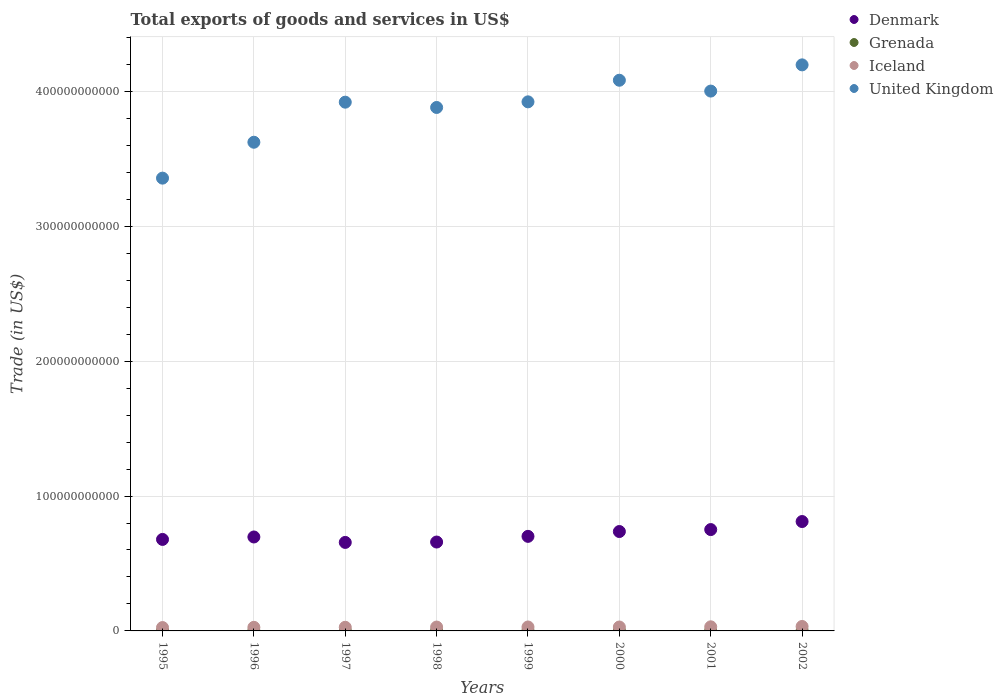How many different coloured dotlines are there?
Provide a succinct answer. 4. What is the total exports of goods and services in Grenada in 1999?
Offer a terse response. 2.18e+08. Across all years, what is the maximum total exports of goods and services in Iceland?
Your response must be concise. 3.30e+09. Across all years, what is the minimum total exports of goods and services in Grenada?
Offer a terse response. 1.24e+08. What is the total total exports of goods and services in United Kingdom in the graph?
Your answer should be very brief. 3.10e+12. What is the difference between the total exports of goods and services in Grenada in 1995 and that in 1996?
Make the answer very short. -7.80e+06. What is the difference between the total exports of goods and services in United Kingdom in 2002 and the total exports of goods and services in Iceland in 1999?
Give a very brief answer. 4.17e+11. What is the average total exports of goods and services in Iceland per year?
Provide a succinct answer. 2.86e+09. In the year 1996, what is the difference between the total exports of goods and services in Iceland and total exports of goods and services in Denmark?
Your answer should be compact. -6.70e+1. What is the ratio of the total exports of goods and services in United Kingdom in 1997 to that in 1998?
Provide a succinct answer. 1.01. What is the difference between the highest and the second highest total exports of goods and services in United Kingdom?
Your answer should be very brief. 1.14e+1. What is the difference between the highest and the lowest total exports of goods and services in Denmark?
Make the answer very short. 1.55e+1. Is the sum of the total exports of goods and services in United Kingdom in 1996 and 1997 greater than the maximum total exports of goods and services in Iceland across all years?
Provide a short and direct response. Yes. Is it the case that in every year, the sum of the total exports of goods and services in Denmark and total exports of goods and services in United Kingdom  is greater than the sum of total exports of goods and services in Iceland and total exports of goods and services in Grenada?
Provide a short and direct response. Yes. Is it the case that in every year, the sum of the total exports of goods and services in Grenada and total exports of goods and services in Denmark  is greater than the total exports of goods and services in United Kingdom?
Your answer should be very brief. No. Is the total exports of goods and services in Denmark strictly greater than the total exports of goods and services in United Kingdom over the years?
Make the answer very short. No. Is the total exports of goods and services in United Kingdom strictly less than the total exports of goods and services in Grenada over the years?
Give a very brief answer. No. How many years are there in the graph?
Provide a short and direct response. 8. What is the difference between two consecutive major ticks on the Y-axis?
Your answer should be very brief. 1.00e+11. Are the values on the major ticks of Y-axis written in scientific E-notation?
Keep it short and to the point. No. Does the graph contain any zero values?
Your response must be concise. No. Does the graph contain grids?
Offer a very short reply. Yes. Where does the legend appear in the graph?
Make the answer very short. Top right. What is the title of the graph?
Offer a terse response. Total exports of goods and services in US$. What is the label or title of the Y-axis?
Make the answer very short. Trade (in US$). What is the Trade (in US$) of Denmark in 1995?
Make the answer very short. 6.78e+1. What is the Trade (in US$) of Grenada in 1995?
Offer a terse response. 1.24e+08. What is the Trade (in US$) in Iceland in 1995?
Provide a succinct answer. 2.49e+09. What is the Trade (in US$) in United Kingdom in 1995?
Your answer should be compact. 3.36e+11. What is the Trade (in US$) of Denmark in 1996?
Offer a very short reply. 6.96e+1. What is the Trade (in US$) of Grenada in 1996?
Offer a terse response. 1.32e+08. What is the Trade (in US$) in Iceland in 1996?
Your answer should be compact. 2.66e+09. What is the Trade (in US$) of United Kingdom in 1996?
Offer a very short reply. 3.62e+11. What is the Trade (in US$) of Denmark in 1997?
Your answer should be compact. 6.56e+1. What is the Trade (in US$) in Grenada in 1997?
Provide a short and direct response. 1.34e+08. What is the Trade (in US$) in Iceland in 1997?
Give a very brief answer. 2.69e+09. What is the Trade (in US$) in United Kingdom in 1997?
Make the answer very short. 3.92e+11. What is the Trade (in US$) of Denmark in 1998?
Your response must be concise. 6.59e+1. What is the Trade (in US$) in Grenada in 1998?
Offer a very short reply. 1.57e+08. What is the Trade (in US$) in Iceland in 1998?
Offer a terse response. 2.87e+09. What is the Trade (in US$) of United Kingdom in 1998?
Give a very brief answer. 3.88e+11. What is the Trade (in US$) of Denmark in 1999?
Give a very brief answer. 7.01e+1. What is the Trade (in US$) in Grenada in 1999?
Give a very brief answer. 2.18e+08. What is the Trade (in US$) of Iceland in 1999?
Your answer should be very brief. 2.92e+09. What is the Trade (in US$) of United Kingdom in 1999?
Provide a succinct answer. 3.92e+11. What is the Trade (in US$) in Denmark in 2000?
Keep it short and to the point. 7.37e+1. What is the Trade (in US$) in Grenada in 2000?
Provide a succinct answer. 2.36e+08. What is the Trade (in US$) of Iceland in 2000?
Ensure brevity in your answer.  2.90e+09. What is the Trade (in US$) in United Kingdom in 2000?
Offer a very short reply. 4.08e+11. What is the Trade (in US$) in Denmark in 2001?
Your answer should be compact. 7.51e+1. What is the Trade (in US$) of Grenada in 2001?
Give a very brief answer. 1.97e+08. What is the Trade (in US$) in Iceland in 2001?
Your response must be concise. 3.04e+09. What is the Trade (in US$) of United Kingdom in 2001?
Offer a terse response. 4.00e+11. What is the Trade (in US$) in Denmark in 2002?
Keep it short and to the point. 8.11e+1. What is the Trade (in US$) of Grenada in 2002?
Keep it short and to the point. 1.73e+08. What is the Trade (in US$) in Iceland in 2002?
Your answer should be compact. 3.30e+09. What is the Trade (in US$) in United Kingdom in 2002?
Keep it short and to the point. 4.20e+11. Across all years, what is the maximum Trade (in US$) of Denmark?
Your answer should be very brief. 8.11e+1. Across all years, what is the maximum Trade (in US$) in Grenada?
Your answer should be compact. 2.36e+08. Across all years, what is the maximum Trade (in US$) in Iceland?
Offer a terse response. 3.30e+09. Across all years, what is the maximum Trade (in US$) of United Kingdom?
Keep it short and to the point. 4.20e+11. Across all years, what is the minimum Trade (in US$) of Denmark?
Ensure brevity in your answer.  6.56e+1. Across all years, what is the minimum Trade (in US$) of Grenada?
Provide a short and direct response. 1.24e+08. Across all years, what is the minimum Trade (in US$) in Iceland?
Ensure brevity in your answer.  2.49e+09. Across all years, what is the minimum Trade (in US$) in United Kingdom?
Offer a very short reply. 3.36e+11. What is the total Trade (in US$) in Denmark in the graph?
Provide a succinct answer. 5.69e+11. What is the total Trade (in US$) of Grenada in the graph?
Your answer should be very brief. 1.37e+09. What is the total Trade (in US$) in Iceland in the graph?
Your answer should be very brief. 2.29e+1. What is the total Trade (in US$) in United Kingdom in the graph?
Provide a short and direct response. 3.10e+12. What is the difference between the Trade (in US$) in Denmark in 1995 and that in 1996?
Make the answer very short. -1.81e+09. What is the difference between the Trade (in US$) of Grenada in 1995 and that in 1996?
Your answer should be compact. -7.80e+06. What is the difference between the Trade (in US$) of Iceland in 1995 and that in 1996?
Offer a terse response. -1.67e+08. What is the difference between the Trade (in US$) in United Kingdom in 1995 and that in 1996?
Your response must be concise. -2.66e+1. What is the difference between the Trade (in US$) in Denmark in 1995 and that in 1997?
Offer a very short reply. 2.22e+09. What is the difference between the Trade (in US$) in Grenada in 1995 and that in 1997?
Your answer should be compact. -1.03e+07. What is the difference between the Trade (in US$) in Iceland in 1995 and that in 1997?
Ensure brevity in your answer.  -1.96e+08. What is the difference between the Trade (in US$) of United Kingdom in 1995 and that in 1997?
Provide a succinct answer. -5.63e+1. What is the difference between the Trade (in US$) in Denmark in 1995 and that in 1998?
Make the answer very short. 1.93e+09. What is the difference between the Trade (in US$) of Grenada in 1995 and that in 1998?
Your response must be concise. -3.36e+07. What is the difference between the Trade (in US$) in Iceland in 1995 and that in 1998?
Provide a succinct answer. -3.78e+08. What is the difference between the Trade (in US$) of United Kingdom in 1995 and that in 1998?
Your answer should be compact. -5.24e+1. What is the difference between the Trade (in US$) of Denmark in 1995 and that in 1999?
Offer a terse response. -2.27e+09. What is the difference between the Trade (in US$) of Grenada in 1995 and that in 1999?
Keep it short and to the point. -9.42e+07. What is the difference between the Trade (in US$) in Iceland in 1995 and that in 1999?
Ensure brevity in your answer.  -4.22e+08. What is the difference between the Trade (in US$) of United Kingdom in 1995 and that in 1999?
Make the answer very short. -5.66e+1. What is the difference between the Trade (in US$) in Denmark in 1995 and that in 2000?
Provide a short and direct response. -5.86e+09. What is the difference between the Trade (in US$) of Grenada in 1995 and that in 2000?
Offer a very short reply. -1.12e+08. What is the difference between the Trade (in US$) in Iceland in 1995 and that in 2000?
Ensure brevity in your answer.  -4.06e+08. What is the difference between the Trade (in US$) of United Kingdom in 1995 and that in 2000?
Offer a terse response. -7.26e+1. What is the difference between the Trade (in US$) in Denmark in 1995 and that in 2001?
Provide a succinct answer. -7.30e+09. What is the difference between the Trade (in US$) of Grenada in 1995 and that in 2001?
Your response must be concise. -7.33e+07. What is the difference between the Trade (in US$) in Iceland in 1995 and that in 2001?
Ensure brevity in your answer.  -5.47e+08. What is the difference between the Trade (in US$) of United Kingdom in 1995 and that in 2001?
Provide a short and direct response. -6.45e+1. What is the difference between the Trade (in US$) of Denmark in 1995 and that in 2002?
Your response must be concise. -1.33e+1. What is the difference between the Trade (in US$) in Grenada in 1995 and that in 2002?
Offer a very short reply. -4.88e+07. What is the difference between the Trade (in US$) of Iceland in 1995 and that in 2002?
Provide a succinct answer. -8.09e+08. What is the difference between the Trade (in US$) in United Kingdom in 1995 and that in 2002?
Your answer should be very brief. -8.40e+1. What is the difference between the Trade (in US$) of Denmark in 1996 and that in 1997?
Offer a very short reply. 4.03e+09. What is the difference between the Trade (in US$) of Grenada in 1996 and that in 1997?
Offer a terse response. -2.47e+06. What is the difference between the Trade (in US$) in Iceland in 1996 and that in 1997?
Keep it short and to the point. -2.97e+07. What is the difference between the Trade (in US$) in United Kingdom in 1996 and that in 1997?
Your response must be concise. -2.97e+1. What is the difference between the Trade (in US$) of Denmark in 1996 and that in 1998?
Offer a very short reply. 3.75e+09. What is the difference between the Trade (in US$) of Grenada in 1996 and that in 1998?
Offer a very short reply. -2.58e+07. What is the difference between the Trade (in US$) of Iceland in 1996 and that in 1998?
Keep it short and to the point. -2.11e+08. What is the difference between the Trade (in US$) in United Kingdom in 1996 and that in 1998?
Offer a terse response. -2.58e+1. What is the difference between the Trade (in US$) in Denmark in 1996 and that in 1999?
Give a very brief answer. -4.60e+08. What is the difference between the Trade (in US$) in Grenada in 1996 and that in 1999?
Ensure brevity in your answer.  -8.64e+07. What is the difference between the Trade (in US$) in Iceland in 1996 and that in 1999?
Give a very brief answer. -2.55e+08. What is the difference between the Trade (in US$) of United Kingdom in 1996 and that in 1999?
Your answer should be very brief. -2.99e+1. What is the difference between the Trade (in US$) in Denmark in 1996 and that in 2000?
Offer a terse response. -4.04e+09. What is the difference between the Trade (in US$) in Grenada in 1996 and that in 2000?
Give a very brief answer. -1.04e+08. What is the difference between the Trade (in US$) of Iceland in 1996 and that in 2000?
Offer a terse response. -2.39e+08. What is the difference between the Trade (in US$) of United Kingdom in 1996 and that in 2000?
Ensure brevity in your answer.  -4.60e+1. What is the difference between the Trade (in US$) of Denmark in 1996 and that in 2001?
Provide a short and direct response. -5.49e+09. What is the difference between the Trade (in US$) in Grenada in 1996 and that in 2001?
Provide a succinct answer. -6.55e+07. What is the difference between the Trade (in US$) of Iceland in 1996 and that in 2001?
Keep it short and to the point. -3.80e+08. What is the difference between the Trade (in US$) of United Kingdom in 1996 and that in 2001?
Your answer should be compact. -3.79e+1. What is the difference between the Trade (in US$) of Denmark in 1996 and that in 2002?
Provide a short and direct response. -1.15e+1. What is the difference between the Trade (in US$) in Grenada in 1996 and that in 2002?
Provide a short and direct response. -4.10e+07. What is the difference between the Trade (in US$) in Iceland in 1996 and that in 2002?
Give a very brief answer. -6.42e+08. What is the difference between the Trade (in US$) in United Kingdom in 1996 and that in 2002?
Make the answer very short. -5.74e+1. What is the difference between the Trade (in US$) of Denmark in 1997 and that in 1998?
Your answer should be compact. -2.83e+08. What is the difference between the Trade (in US$) of Grenada in 1997 and that in 1998?
Your answer should be compact. -2.33e+07. What is the difference between the Trade (in US$) of Iceland in 1997 and that in 1998?
Make the answer very short. -1.82e+08. What is the difference between the Trade (in US$) in United Kingdom in 1997 and that in 1998?
Offer a very short reply. 3.92e+09. What is the difference between the Trade (in US$) of Denmark in 1997 and that in 1999?
Give a very brief answer. -4.49e+09. What is the difference between the Trade (in US$) of Grenada in 1997 and that in 1999?
Ensure brevity in your answer.  -8.40e+07. What is the difference between the Trade (in US$) of Iceland in 1997 and that in 1999?
Your answer should be compact. -2.25e+08. What is the difference between the Trade (in US$) in United Kingdom in 1997 and that in 1999?
Your answer should be very brief. -2.45e+08. What is the difference between the Trade (in US$) in Denmark in 1997 and that in 2000?
Your answer should be very brief. -8.07e+09. What is the difference between the Trade (in US$) in Grenada in 1997 and that in 2000?
Ensure brevity in your answer.  -1.02e+08. What is the difference between the Trade (in US$) of Iceland in 1997 and that in 2000?
Give a very brief answer. -2.10e+08. What is the difference between the Trade (in US$) in United Kingdom in 1997 and that in 2000?
Your response must be concise. -1.63e+1. What is the difference between the Trade (in US$) in Denmark in 1997 and that in 2001?
Offer a terse response. -9.52e+09. What is the difference between the Trade (in US$) of Grenada in 1997 and that in 2001?
Provide a succinct answer. -6.31e+07. What is the difference between the Trade (in US$) of Iceland in 1997 and that in 2001?
Keep it short and to the point. -3.51e+08. What is the difference between the Trade (in US$) of United Kingdom in 1997 and that in 2001?
Offer a very short reply. -8.23e+09. What is the difference between the Trade (in US$) of Denmark in 1997 and that in 2002?
Give a very brief answer. -1.55e+1. What is the difference between the Trade (in US$) in Grenada in 1997 and that in 2002?
Give a very brief answer. -3.85e+07. What is the difference between the Trade (in US$) of Iceland in 1997 and that in 2002?
Provide a succinct answer. -6.13e+08. What is the difference between the Trade (in US$) of United Kingdom in 1997 and that in 2002?
Make the answer very short. -2.77e+1. What is the difference between the Trade (in US$) of Denmark in 1998 and that in 1999?
Offer a very short reply. -4.21e+09. What is the difference between the Trade (in US$) of Grenada in 1998 and that in 1999?
Provide a short and direct response. -6.06e+07. What is the difference between the Trade (in US$) in Iceland in 1998 and that in 1999?
Give a very brief answer. -4.36e+07. What is the difference between the Trade (in US$) in United Kingdom in 1998 and that in 1999?
Your answer should be very brief. -4.17e+09. What is the difference between the Trade (in US$) of Denmark in 1998 and that in 2000?
Provide a succinct answer. -7.79e+09. What is the difference between the Trade (in US$) in Grenada in 1998 and that in 2000?
Keep it short and to the point. -7.83e+07. What is the difference between the Trade (in US$) of Iceland in 1998 and that in 2000?
Your answer should be compact. -2.80e+07. What is the difference between the Trade (in US$) in United Kingdom in 1998 and that in 2000?
Offer a terse response. -2.02e+1. What is the difference between the Trade (in US$) in Denmark in 1998 and that in 2001?
Ensure brevity in your answer.  -9.24e+09. What is the difference between the Trade (in US$) in Grenada in 1998 and that in 2001?
Your answer should be compact. -3.97e+07. What is the difference between the Trade (in US$) in Iceland in 1998 and that in 2001?
Provide a succinct answer. -1.69e+08. What is the difference between the Trade (in US$) of United Kingdom in 1998 and that in 2001?
Make the answer very short. -1.21e+1. What is the difference between the Trade (in US$) in Denmark in 1998 and that in 2002?
Give a very brief answer. -1.52e+1. What is the difference between the Trade (in US$) of Grenada in 1998 and that in 2002?
Provide a short and direct response. -1.52e+07. What is the difference between the Trade (in US$) in Iceland in 1998 and that in 2002?
Your response must be concise. -4.31e+08. What is the difference between the Trade (in US$) in United Kingdom in 1998 and that in 2002?
Ensure brevity in your answer.  -3.16e+1. What is the difference between the Trade (in US$) in Denmark in 1999 and that in 2000?
Provide a succinct answer. -3.58e+09. What is the difference between the Trade (in US$) in Grenada in 1999 and that in 2000?
Your answer should be very brief. -1.77e+07. What is the difference between the Trade (in US$) of Iceland in 1999 and that in 2000?
Ensure brevity in your answer.  1.56e+07. What is the difference between the Trade (in US$) in United Kingdom in 1999 and that in 2000?
Offer a terse response. -1.60e+1. What is the difference between the Trade (in US$) in Denmark in 1999 and that in 2001?
Offer a very short reply. -5.03e+09. What is the difference between the Trade (in US$) in Grenada in 1999 and that in 2001?
Your answer should be very brief. 2.09e+07. What is the difference between the Trade (in US$) in Iceland in 1999 and that in 2001?
Ensure brevity in your answer.  -1.25e+08. What is the difference between the Trade (in US$) of United Kingdom in 1999 and that in 2001?
Ensure brevity in your answer.  -7.98e+09. What is the difference between the Trade (in US$) in Denmark in 1999 and that in 2002?
Your response must be concise. -1.10e+1. What is the difference between the Trade (in US$) in Grenada in 1999 and that in 2002?
Your response must be concise. 4.54e+07. What is the difference between the Trade (in US$) in Iceland in 1999 and that in 2002?
Provide a succinct answer. -3.87e+08. What is the difference between the Trade (in US$) in United Kingdom in 1999 and that in 2002?
Make the answer very short. -2.74e+1. What is the difference between the Trade (in US$) of Denmark in 2000 and that in 2001?
Provide a short and direct response. -1.45e+09. What is the difference between the Trade (in US$) of Grenada in 2000 and that in 2001?
Offer a very short reply. 3.86e+07. What is the difference between the Trade (in US$) in Iceland in 2000 and that in 2001?
Provide a short and direct response. -1.41e+08. What is the difference between the Trade (in US$) of United Kingdom in 2000 and that in 2001?
Provide a short and direct response. 8.04e+09. What is the difference between the Trade (in US$) in Denmark in 2000 and that in 2002?
Your answer should be compact. -7.41e+09. What is the difference between the Trade (in US$) of Grenada in 2000 and that in 2002?
Your answer should be very brief. 6.31e+07. What is the difference between the Trade (in US$) in Iceland in 2000 and that in 2002?
Offer a very short reply. -4.03e+08. What is the difference between the Trade (in US$) of United Kingdom in 2000 and that in 2002?
Ensure brevity in your answer.  -1.14e+1. What is the difference between the Trade (in US$) in Denmark in 2001 and that in 2002?
Offer a very short reply. -5.96e+09. What is the difference between the Trade (in US$) in Grenada in 2001 and that in 2002?
Offer a very short reply. 2.45e+07. What is the difference between the Trade (in US$) in Iceland in 2001 and that in 2002?
Offer a very short reply. -2.62e+08. What is the difference between the Trade (in US$) of United Kingdom in 2001 and that in 2002?
Make the answer very short. -1.94e+1. What is the difference between the Trade (in US$) of Denmark in 1995 and the Trade (in US$) of Grenada in 1996?
Offer a very short reply. 6.77e+1. What is the difference between the Trade (in US$) in Denmark in 1995 and the Trade (in US$) in Iceland in 1996?
Give a very brief answer. 6.52e+1. What is the difference between the Trade (in US$) in Denmark in 1995 and the Trade (in US$) in United Kingdom in 1996?
Provide a short and direct response. -2.94e+11. What is the difference between the Trade (in US$) of Grenada in 1995 and the Trade (in US$) of Iceland in 1996?
Provide a short and direct response. -2.54e+09. What is the difference between the Trade (in US$) in Grenada in 1995 and the Trade (in US$) in United Kingdom in 1996?
Ensure brevity in your answer.  -3.62e+11. What is the difference between the Trade (in US$) of Iceland in 1995 and the Trade (in US$) of United Kingdom in 1996?
Your response must be concise. -3.60e+11. What is the difference between the Trade (in US$) of Denmark in 1995 and the Trade (in US$) of Grenada in 1997?
Provide a short and direct response. 6.77e+1. What is the difference between the Trade (in US$) of Denmark in 1995 and the Trade (in US$) of Iceland in 1997?
Offer a terse response. 6.51e+1. What is the difference between the Trade (in US$) in Denmark in 1995 and the Trade (in US$) in United Kingdom in 1997?
Provide a short and direct response. -3.24e+11. What is the difference between the Trade (in US$) in Grenada in 1995 and the Trade (in US$) in Iceland in 1997?
Give a very brief answer. -2.57e+09. What is the difference between the Trade (in US$) in Grenada in 1995 and the Trade (in US$) in United Kingdom in 1997?
Your response must be concise. -3.92e+11. What is the difference between the Trade (in US$) of Iceland in 1995 and the Trade (in US$) of United Kingdom in 1997?
Your answer should be very brief. -3.90e+11. What is the difference between the Trade (in US$) of Denmark in 1995 and the Trade (in US$) of Grenada in 1998?
Your response must be concise. 6.77e+1. What is the difference between the Trade (in US$) in Denmark in 1995 and the Trade (in US$) in Iceland in 1998?
Ensure brevity in your answer.  6.50e+1. What is the difference between the Trade (in US$) in Denmark in 1995 and the Trade (in US$) in United Kingdom in 1998?
Provide a succinct answer. -3.20e+11. What is the difference between the Trade (in US$) in Grenada in 1995 and the Trade (in US$) in Iceland in 1998?
Your answer should be very brief. -2.75e+09. What is the difference between the Trade (in US$) of Grenada in 1995 and the Trade (in US$) of United Kingdom in 1998?
Keep it short and to the point. -3.88e+11. What is the difference between the Trade (in US$) of Iceland in 1995 and the Trade (in US$) of United Kingdom in 1998?
Ensure brevity in your answer.  -3.86e+11. What is the difference between the Trade (in US$) in Denmark in 1995 and the Trade (in US$) in Grenada in 1999?
Your response must be concise. 6.76e+1. What is the difference between the Trade (in US$) of Denmark in 1995 and the Trade (in US$) of Iceland in 1999?
Your answer should be very brief. 6.49e+1. What is the difference between the Trade (in US$) of Denmark in 1995 and the Trade (in US$) of United Kingdom in 1999?
Make the answer very short. -3.24e+11. What is the difference between the Trade (in US$) of Grenada in 1995 and the Trade (in US$) of Iceland in 1999?
Your answer should be very brief. -2.79e+09. What is the difference between the Trade (in US$) of Grenada in 1995 and the Trade (in US$) of United Kingdom in 1999?
Give a very brief answer. -3.92e+11. What is the difference between the Trade (in US$) of Iceland in 1995 and the Trade (in US$) of United Kingdom in 1999?
Your answer should be very brief. -3.90e+11. What is the difference between the Trade (in US$) of Denmark in 1995 and the Trade (in US$) of Grenada in 2000?
Provide a short and direct response. 6.76e+1. What is the difference between the Trade (in US$) in Denmark in 1995 and the Trade (in US$) in Iceland in 2000?
Give a very brief answer. 6.49e+1. What is the difference between the Trade (in US$) in Denmark in 1995 and the Trade (in US$) in United Kingdom in 2000?
Your answer should be compact. -3.40e+11. What is the difference between the Trade (in US$) of Grenada in 1995 and the Trade (in US$) of Iceland in 2000?
Your answer should be very brief. -2.78e+09. What is the difference between the Trade (in US$) of Grenada in 1995 and the Trade (in US$) of United Kingdom in 2000?
Provide a succinct answer. -4.08e+11. What is the difference between the Trade (in US$) of Iceland in 1995 and the Trade (in US$) of United Kingdom in 2000?
Offer a terse response. -4.06e+11. What is the difference between the Trade (in US$) in Denmark in 1995 and the Trade (in US$) in Grenada in 2001?
Your response must be concise. 6.76e+1. What is the difference between the Trade (in US$) of Denmark in 1995 and the Trade (in US$) of Iceland in 2001?
Your response must be concise. 6.48e+1. What is the difference between the Trade (in US$) of Denmark in 1995 and the Trade (in US$) of United Kingdom in 2001?
Your answer should be compact. -3.32e+11. What is the difference between the Trade (in US$) of Grenada in 1995 and the Trade (in US$) of Iceland in 2001?
Offer a terse response. -2.92e+09. What is the difference between the Trade (in US$) of Grenada in 1995 and the Trade (in US$) of United Kingdom in 2001?
Make the answer very short. -4.00e+11. What is the difference between the Trade (in US$) in Iceland in 1995 and the Trade (in US$) in United Kingdom in 2001?
Offer a terse response. -3.98e+11. What is the difference between the Trade (in US$) in Denmark in 1995 and the Trade (in US$) in Grenada in 2002?
Provide a succinct answer. 6.77e+1. What is the difference between the Trade (in US$) in Denmark in 1995 and the Trade (in US$) in Iceland in 2002?
Your response must be concise. 6.45e+1. What is the difference between the Trade (in US$) in Denmark in 1995 and the Trade (in US$) in United Kingdom in 2002?
Ensure brevity in your answer.  -3.52e+11. What is the difference between the Trade (in US$) in Grenada in 1995 and the Trade (in US$) in Iceland in 2002?
Give a very brief answer. -3.18e+09. What is the difference between the Trade (in US$) of Grenada in 1995 and the Trade (in US$) of United Kingdom in 2002?
Keep it short and to the point. -4.20e+11. What is the difference between the Trade (in US$) in Iceland in 1995 and the Trade (in US$) in United Kingdom in 2002?
Your answer should be very brief. -4.17e+11. What is the difference between the Trade (in US$) in Denmark in 1996 and the Trade (in US$) in Grenada in 1997?
Ensure brevity in your answer.  6.95e+1. What is the difference between the Trade (in US$) in Denmark in 1996 and the Trade (in US$) in Iceland in 1997?
Your response must be concise. 6.70e+1. What is the difference between the Trade (in US$) in Denmark in 1996 and the Trade (in US$) in United Kingdom in 1997?
Give a very brief answer. -3.22e+11. What is the difference between the Trade (in US$) of Grenada in 1996 and the Trade (in US$) of Iceland in 1997?
Keep it short and to the point. -2.56e+09. What is the difference between the Trade (in US$) in Grenada in 1996 and the Trade (in US$) in United Kingdom in 1997?
Offer a terse response. -3.92e+11. What is the difference between the Trade (in US$) of Iceland in 1996 and the Trade (in US$) of United Kingdom in 1997?
Give a very brief answer. -3.89e+11. What is the difference between the Trade (in US$) in Denmark in 1996 and the Trade (in US$) in Grenada in 1998?
Keep it short and to the point. 6.95e+1. What is the difference between the Trade (in US$) in Denmark in 1996 and the Trade (in US$) in Iceland in 1998?
Give a very brief answer. 6.68e+1. What is the difference between the Trade (in US$) of Denmark in 1996 and the Trade (in US$) of United Kingdom in 1998?
Provide a succinct answer. -3.18e+11. What is the difference between the Trade (in US$) in Grenada in 1996 and the Trade (in US$) in Iceland in 1998?
Provide a succinct answer. -2.74e+09. What is the difference between the Trade (in US$) of Grenada in 1996 and the Trade (in US$) of United Kingdom in 1998?
Your response must be concise. -3.88e+11. What is the difference between the Trade (in US$) in Iceland in 1996 and the Trade (in US$) in United Kingdom in 1998?
Provide a short and direct response. -3.85e+11. What is the difference between the Trade (in US$) in Denmark in 1996 and the Trade (in US$) in Grenada in 1999?
Make the answer very short. 6.94e+1. What is the difference between the Trade (in US$) in Denmark in 1996 and the Trade (in US$) in Iceland in 1999?
Your answer should be compact. 6.67e+1. What is the difference between the Trade (in US$) in Denmark in 1996 and the Trade (in US$) in United Kingdom in 1999?
Provide a short and direct response. -3.23e+11. What is the difference between the Trade (in US$) in Grenada in 1996 and the Trade (in US$) in Iceland in 1999?
Ensure brevity in your answer.  -2.78e+09. What is the difference between the Trade (in US$) of Grenada in 1996 and the Trade (in US$) of United Kingdom in 1999?
Keep it short and to the point. -3.92e+11. What is the difference between the Trade (in US$) of Iceland in 1996 and the Trade (in US$) of United Kingdom in 1999?
Your answer should be compact. -3.90e+11. What is the difference between the Trade (in US$) in Denmark in 1996 and the Trade (in US$) in Grenada in 2000?
Give a very brief answer. 6.94e+1. What is the difference between the Trade (in US$) in Denmark in 1996 and the Trade (in US$) in Iceland in 2000?
Your answer should be compact. 6.67e+1. What is the difference between the Trade (in US$) of Denmark in 1996 and the Trade (in US$) of United Kingdom in 2000?
Make the answer very short. -3.39e+11. What is the difference between the Trade (in US$) of Grenada in 1996 and the Trade (in US$) of Iceland in 2000?
Offer a terse response. -2.77e+09. What is the difference between the Trade (in US$) of Grenada in 1996 and the Trade (in US$) of United Kingdom in 2000?
Give a very brief answer. -4.08e+11. What is the difference between the Trade (in US$) in Iceland in 1996 and the Trade (in US$) in United Kingdom in 2000?
Ensure brevity in your answer.  -4.06e+11. What is the difference between the Trade (in US$) of Denmark in 1996 and the Trade (in US$) of Grenada in 2001?
Provide a short and direct response. 6.94e+1. What is the difference between the Trade (in US$) in Denmark in 1996 and the Trade (in US$) in Iceland in 2001?
Provide a short and direct response. 6.66e+1. What is the difference between the Trade (in US$) in Denmark in 1996 and the Trade (in US$) in United Kingdom in 2001?
Offer a terse response. -3.31e+11. What is the difference between the Trade (in US$) of Grenada in 1996 and the Trade (in US$) of Iceland in 2001?
Your answer should be very brief. -2.91e+09. What is the difference between the Trade (in US$) of Grenada in 1996 and the Trade (in US$) of United Kingdom in 2001?
Provide a short and direct response. -4.00e+11. What is the difference between the Trade (in US$) in Iceland in 1996 and the Trade (in US$) in United Kingdom in 2001?
Keep it short and to the point. -3.98e+11. What is the difference between the Trade (in US$) in Denmark in 1996 and the Trade (in US$) in Grenada in 2002?
Provide a succinct answer. 6.95e+1. What is the difference between the Trade (in US$) of Denmark in 1996 and the Trade (in US$) of Iceland in 2002?
Keep it short and to the point. 6.63e+1. What is the difference between the Trade (in US$) in Denmark in 1996 and the Trade (in US$) in United Kingdom in 2002?
Your answer should be very brief. -3.50e+11. What is the difference between the Trade (in US$) in Grenada in 1996 and the Trade (in US$) in Iceland in 2002?
Your answer should be very brief. -3.17e+09. What is the difference between the Trade (in US$) of Grenada in 1996 and the Trade (in US$) of United Kingdom in 2002?
Offer a very short reply. -4.20e+11. What is the difference between the Trade (in US$) in Iceland in 1996 and the Trade (in US$) in United Kingdom in 2002?
Keep it short and to the point. -4.17e+11. What is the difference between the Trade (in US$) of Denmark in 1997 and the Trade (in US$) of Grenada in 1998?
Your answer should be very brief. 6.55e+1. What is the difference between the Trade (in US$) of Denmark in 1997 and the Trade (in US$) of Iceland in 1998?
Your answer should be very brief. 6.27e+1. What is the difference between the Trade (in US$) in Denmark in 1997 and the Trade (in US$) in United Kingdom in 1998?
Your answer should be very brief. -3.22e+11. What is the difference between the Trade (in US$) in Grenada in 1997 and the Trade (in US$) in Iceland in 1998?
Offer a very short reply. -2.74e+09. What is the difference between the Trade (in US$) in Grenada in 1997 and the Trade (in US$) in United Kingdom in 1998?
Your response must be concise. -3.88e+11. What is the difference between the Trade (in US$) of Iceland in 1997 and the Trade (in US$) of United Kingdom in 1998?
Provide a short and direct response. -3.85e+11. What is the difference between the Trade (in US$) in Denmark in 1997 and the Trade (in US$) in Grenada in 1999?
Provide a short and direct response. 6.54e+1. What is the difference between the Trade (in US$) of Denmark in 1997 and the Trade (in US$) of Iceland in 1999?
Give a very brief answer. 6.27e+1. What is the difference between the Trade (in US$) in Denmark in 1997 and the Trade (in US$) in United Kingdom in 1999?
Make the answer very short. -3.27e+11. What is the difference between the Trade (in US$) in Grenada in 1997 and the Trade (in US$) in Iceland in 1999?
Provide a succinct answer. -2.78e+09. What is the difference between the Trade (in US$) of Grenada in 1997 and the Trade (in US$) of United Kingdom in 1999?
Offer a terse response. -3.92e+11. What is the difference between the Trade (in US$) of Iceland in 1997 and the Trade (in US$) of United Kingdom in 1999?
Provide a succinct answer. -3.90e+11. What is the difference between the Trade (in US$) in Denmark in 1997 and the Trade (in US$) in Grenada in 2000?
Make the answer very short. 6.54e+1. What is the difference between the Trade (in US$) of Denmark in 1997 and the Trade (in US$) of Iceland in 2000?
Your answer should be very brief. 6.27e+1. What is the difference between the Trade (in US$) of Denmark in 1997 and the Trade (in US$) of United Kingdom in 2000?
Your answer should be compact. -3.43e+11. What is the difference between the Trade (in US$) of Grenada in 1997 and the Trade (in US$) of Iceland in 2000?
Offer a terse response. -2.77e+09. What is the difference between the Trade (in US$) of Grenada in 1997 and the Trade (in US$) of United Kingdom in 2000?
Provide a succinct answer. -4.08e+11. What is the difference between the Trade (in US$) of Iceland in 1997 and the Trade (in US$) of United Kingdom in 2000?
Your answer should be compact. -4.06e+11. What is the difference between the Trade (in US$) in Denmark in 1997 and the Trade (in US$) in Grenada in 2001?
Your response must be concise. 6.54e+1. What is the difference between the Trade (in US$) of Denmark in 1997 and the Trade (in US$) of Iceland in 2001?
Provide a short and direct response. 6.26e+1. What is the difference between the Trade (in US$) in Denmark in 1997 and the Trade (in US$) in United Kingdom in 2001?
Offer a terse response. -3.35e+11. What is the difference between the Trade (in US$) of Grenada in 1997 and the Trade (in US$) of Iceland in 2001?
Make the answer very short. -2.91e+09. What is the difference between the Trade (in US$) in Grenada in 1997 and the Trade (in US$) in United Kingdom in 2001?
Offer a very short reply. -4.00e+11. What is the difference between the Trade (in US$) in Iceland in 1997 and the Trade (in US$) in United Kingdom in 2001?
Keep it short and to the point. -3.98e+11. What is the difference between the Trade (in US$) in Denmark in 1997 and the Trade (in US$) in Grenada in 2002?
Offer a very short reply. 6.54e+1. What is the difference between the Trade (in US$) in Denmark in 1997 and the Trade (in US$) in Iceland in 2002?
Provide a succinct answer. 6.23e+1. What is the difference between the Trade (in US$) in Denmark in 1997 and the Trade (in US$) in United Kingdom in 2002?
Ensure brevity in your answer.  -3.54e+11. What is the difference between the Trade (in US$) of Grenada in 1997 and the Trade (in US$) of Iceland in 2002?
Your answer should be very brief. -3.17e+09. What is the difference between the Trade (in US$) in Grenada in 1997 and the Trade (in US$) in United Kingdom in 2002?
Your answer should be very brief. -4.20e+11. What is the difference between the Trade (in US$) of Iceland in 1997 and the Trade (in US$) of United Kingdom in 2002?
Provide a short and direct response. -4.17e+11. What is the difference between the Trade (in US$) in Denmark in 1998 and the Trade (in US$) in Grenada in 1999?
Provide a short and direct response. 6.57e+1. What is the difference between the Trade (in US$) in Denmark in 1998 and the Trade (in US$) in Iceland in 1999?
Ensure brevity in your answer.  6.30e+1. What is the difference between the Trade (in US$) in Denmark in 1998 and the Trade (in US$) in United Kingdom in 1999?
Make the answer very short. -3.26e+11. What is the difference between the Trade (in US$) in Grenada in 1998 and the Trade (in US$) in Iceland in 1999?
Keep it short and to the point. -2.76e+09. What is the difference between the Trade (in US$) of Grenada in 1998 and the Trade (in US$) of United Kingdom in 1999?
Your response must be concise. -3.92e+11. What is the difference between the Trade (in US$) of Iceland in 1998 and the Trade (in US$) of United Kingdom in 1999?
Your answer should be compact. -3.89e+11. What is the difference between the Trade (in US$) in Denmark in 1998 and the Trade (in US$) in Grenada in 2000?
Offer a very short reply. 6.57e+1. What is the difference between the Trade (in US$) of Denmark in 1998 and the Trade (in US$) of Iceland in 2000?
Keep it short and to the point. 6.30e+1. What is the difference between the Trade (in US$) of Denmark in 1998 and the Trade (in US$) of United Kingdom in 2000?
Make the answer very short. -3.42e+11. What is the difference between the Trade (in US$) in Grenada in 1998 and the Trade (in US$) in Iceland in 2000?
Your response must be concise. -2.74e+09. What is the difference between the Trade (in US$) of Grenada in 1998 and the Trade (in US$) of United Kingdom in 2000?
Provide a succinct answer. -4.08e+11. What is the difference between the Trade (in US$) in Iceland in 1998 and the Trade (in US$) in United Kingdom in 2000?
Provide a short and direct response. -4.05e+11. What is the difference between the Trade (in US$) of Denmark in 1998 and the Trade (in US$) of Grenada in 2001?
Offer a terse response. 6.57e+1. What is the difference between the Trade (in US$) in Denmark in 1998 and the Trade (in US$) in Iceland in 2001?
Ensure brevity in your answer.  6.29e+1. What is the difference between the Trade (in US$) of Denmark in 1998 and the Trade (in US$) of United Kingdom in 2001?
Offer a very short reply. -3.34e+11. What is the difference between the Trade (in US$) of Grenada in 1998 and the Trade (in US$) of Iceland in 2001?
Make the answer very short. -2.88e+09. What is the difference between the Trade (in US$) of Grenada in 1998 and the Trade (in US$) of United Kingdom in 2001?
Keep it short and to the point. -4.00e+11. What is the difference between the Trade (in US$) of Iceland in 1998 and the Trade (in US$) of United Kingdom in 2001?
Your answer should be very brief. -3.97e+11. What is the difference between the Trade (in US$) in Denmark in 1998 and the Trade (in US$) in Grenada in 2002?
Your response must be concise. 6.57e+1. What is the difference between the Trade (in US$) in Denmark in 1998 and the Trade (in US$) in Iceland in 2002?
Offer a very short reply. 6.26e+1. What is the difference between the Trade (in US$) in Denmark in 1998 and the Trade (in US$) in United Kingdom in 2002?
Your response must be concise. -3.54e+11. What is the difference between the Trade (in US$) in Grenada in 1998 and the Trade (in US$) in Iceland in 2002?
Ensure brevity in your answer.  -3.15e+09. What is the difference between the Trade (in US$) of Grenada in 1998 and the Trade (in US$) of United Kingdom in 2002?
Offer a very short reply. -4.20e+11. What is the difference between the Trade (in US$) of Iceland in 1998 and the Trade (in US$) of United Kingdom in 2002?
Your answer should be very brief. -4.17e+11. What is the difference between the Trade (in US$) of Denmark in 1999 and the Trade (in US$) of Grenada in 2000?
Make the answer very short. 6.99e+1. What is the difference between the Trade (in US$) of Denmark in 1999 and the Trade (in US$) of Iceland in 2000?
Your response must be concise. 6.72e+1. What is the difference between the Trade (in US$) in Denmark in 1999 and the Trade (in US$) in United Kingdom in 2000?
Your answer should be very brief. -3.38e+11. What is the difference between the Trade (in US$) of Grenada in 1999 and the Trade (in US$) of Iceland in 2000?
Your response must be concise. -2.68e+09. What is the difference between the Trade (in US$) in Grenada in 1999 and the Trade (in US$) in United Kingdom in 2000?
Provide a short and direct response. -4.08e+11. What is the difference between the Trade (in US$) of Iceland in 1999 and the Trade (in US$) of United Kingdom in 2000?
Your answer should be compact. -4.05e+11. What is the difference between the Trade (in US$) in Denmark in 1999 and the Trade (in US$) in Grenada in 2001?
Keep it short and to the point. 6.99e+1. What is the difference between the Trade (in US$) in Denmark in 1999 and the Trade (in US$) in Iceland in 2001?
Your answer should be compact. 6.71e+1. What is the difference between the Trade (in US$) of Denmark in 1999 and the Trade (in US$) of United Kingdom in 2001?
Give a very brief answer. -3.30e+11. What is the difference between the Trade (in US$) of Grenada in 1999 and the Trade (in US$) of Iceland in 2001?
Offer a very short reply. -2.82e+09. What is the difference between the Trade (in US$) of Grenada in 1999 and the Trade (in US$) of United Kingdom in 2001?
Your answer should be compact. -4.00e+11. What is the difference between the Trade (in US$) of Iceland in 1999 and the Trade (in US$) of United Kingdom in 2001?
Give a very brief answer. -3.97e+11. What is the difference between the Trade (in US$) in Denmark in 1999 and the Trade (in US$) in Grenada in 2002?
Give a very brief answer. 6.99e+1. What is the difference between the Trade (in US$) of Denmark in 1999 and the Trade (in US$) of Iceland in 2002?
Keep it short and to the point. 6.68e+1. What is the difference between the Trade (in US$) of Denmark in 1999 and the Trade (in US$) of United Kingdom in 2002?
Make the answer very short. -3.50e+11. What is the difference between the Trade (in US$) in Grenada in 1999 and the Trade (in US$) in Iceland in 2002?
Offer a terse response. -3.08e+09. What is the difference between the Trade (in US$) of Grenada in 1999 and the Trade (in US$) of United Kingdom in 2002?
Offer a terse response. -4.19e+11. What is the difference between the Trade (in US$) in Iceland in 1999 and the Trade (in US$) in United Kingdom in 2002?
Make the answer very short. -4.17e+11. What is the difference between the Trade (in US$) in Denmark in 2000 and the Trade (in US$) in Grenada in 2001?
Your answer should be very brief. 7.35e+1. What is the difference between the Trade (in US$) of Denmark in 2000 and the Trade (in US$) of Iceland in 2001?
Ensure brevity in your answer.  7.06e+1. What is the difference between the Trade (in US$) in Denmark in 2000 and the Trade (in US$) in United Kingdom in 2001?
Make the answer very short. -3.27e+11. What is the difference between the Trade (in US$) of Grenada in 2000 and the Trade (in US$) of Iceland in 2001?
Your answer should be compact. -2.80e+09. What is the difference between the Trade (in US$) in Grenada in 2000 and the Trade (in US$) in United Kingdom in 2001?
Give a very brief answer. -4.00e+11. What is the difference between the Trade (in US$) of Iceland in 2000 and the Trade (in US$) of United Kingdom in 2001?
Offer a terse response. -3.97e+11. What is the difference between the Trade (in US$) of Denmark in 2000 and the Trade (in US$) of Grenada in 2002?
Offer a terse response. 7.35e+1. What is the difference between the Trade (in US$) of Denmark in 2000 and the Trade (in US$) of Iceland in 2002?
Provide a short and direct response. 7.04e+1. What is the difference between the Trade (in US$) in Denmark in 2000 and the Trade (in US$) in United Kingdom in 2002?
Keep it short and to the point. -3.46e+11. What is the difference between the Trade (in US$) of Grenada in 2000 and the Trade (in US$) of Iceland in 2002?
Keep it short and to the point. -3.07e+09. What is the difference between the Trade (in US$) in Grenada in 2000 and the Trade (in US$) in United Kingdom in 2002?
Keep it short and to the point. -4.19e+11. What is the difference between the Trade (in US$) in Iceland in 2000 and the Trade (in US$) in United Kingdom in 2002?
Give a very brief answer. -4.17e+11. What is the difference between the Trade (in US$) of Denmark in 2001 and the Trade (in US$) of Grenada in 2002?
Offer a very short reply. 7.50e+1. What is the difference between the Trade (in US$) in Denmark in 2001 and the Trade (in US$) in Iceland in 2002?
Make the answer very short. 7.18e+1. What is the difference between the Trade (in US$) in Denmark in 2001 and the Trade (in US$) in United Kingdom in 2002?
Ensure brevity in your answer.  -3.45e+11. What is the difference between the Trade (in US$) of Grenada in 2001 and the Trade (in US$) of Iceland in 2002?
Ensure brevity in your answer.  -3.11e+09. What is the difference between the Trade (in US$) in Grenada in 2001 and the Trade (in US$) in United Kingdom in 2002?
Provide a succinct answer. -4.19e+11. What is the difference between the Trade (in US$) in Iceland in 2001 and the Trade (in US$) in United Kingdom in 2002?
Offer a very short reply. -4.17e+11. What is the average Trade (in US$) in Denmark per year?
Give a very brief answer. 7.11e+1. What is the average Trade (in US$) in Grenada per year?
Offer a very short reply. 1.71e+08. What is the average Trade (in US$) of Iceland per year?
Offer a very short reply. 2.86e+09. What is the average Trade (in US$) of United Kingdom per year?
Provide a succinct answer. 3.87e+11. In the year 1995, what is the difference between the Trade (in US$) of Denmark and Trade (in US$) of Grenada?
Your answer should be compact. 6.77e+1. In the year 1995, what is the difference between the Trade (in US$) in Denmark and Trade (in US$) in Iceland?
Your response must be concise. 6.53e+1. In the year 1995, what is the difference between the Trade (in US$) in Denmark and Trade (in US$) in United Kingdom?
Ensure brevity in your answer.  -2.68e+11. In the year 1995, what is the difference between the Trade (in US$) of Grenada and Trade (in US$) of Iceland?
Your response must be concise. -2.37e+09. In the year 1995, what is the difference between the Trade (in US$) of Grenada and Trade (in US$) of United Kingdom?
Your answer should be compact. -3.36e+11. In the year 1995, what is the difference between the Trade (in US$) of Iceland and Trade (in US$) of United Kingdom?
Keep it short and to the point. -3.33e+11. In the year 1996, what is the difference between the Trade (in US$) in Denmark and Trade (in US$) in Grenada?
Your answer should be compact. 6.95e+1. In the year 1996, what is the difference between the Trade (in US$) in Denmark and Trade (in US$) in Iceland?
Provide a succinct answer. 6.70e+1. In the year 1996, what is the difference between the Trade (in US$) in Denmark and Trade (in US$) in United Kingdom?
Ensure brevity in your answer.  -2.93e+11. In the year 1996, what is the difference between the Trade (in US$) in Grenada and Trade (in US$) in Iceland?
Your answer should be compact. -2.53e+09. In the year 1996, what is the difference between the Trade (in US$) of Grenada and Trade (in US$) of United Kingdom?
Ensure brevity in your answer.  -3.62e+11. In the year 1996, what is the difference between the Trade (in US$) of Iceland and Trade (in US$) of United Kingdom?
Ensure brevity in your answer.  -3.60e+11. In the year 1997, what is the difference between the Trade (in US$) of Denmark and Trade (in US$) of Grenada?
Keep it short and to the point. 6.55e+1. In the year 1997, what is the difference between the Trade (in US$) of Denmark and Trade (in US$) of Iceland?
Your answer should be compact. 6.29e+1. In the year 1997, what is the difference between the Trade (in US$) in Denmark and Trade (in US$) in United Kingdom?
Your answer should be very brief. -3.26e+11. In the year 1997, what is the difference between the Trade (in US$) in Grenada and Trade (in US$) in Iceland?
Provide a short and direct response. -2.56e+09. In the year 1997, what is the difference between the Trade (in US$) in Grenada and Trade (in US$) in United Kingdom?
Give a very brief answer. -3.92e+11. In the year 1997, what is the difference between the Trade (in US$) in Iceland and Trade (in US$) in United Kingdom?
Your answer should be very brief. -3.89e+11. In the year 1998, what is the difference between the Trade (in US$) of Denmark and Trade (in US$) of Grenada?
Offer a terse response. 6.57e+1. In the year 1998, what is the difference between the Trade (in US$) in Denmark and Trade (in US$) in Iceland?
Offer a very short reply. 6.30e+1. In the year 1998, what is the difference between the Trade (in US$) in Denmark and Trade (in US$) in United Kingdom?
Provide a succinct answer. -3.22e+11. In the year 1998, what is the difference between the Trade (in US$) of Grenada and Trade (in US$) of Iceland?
Provide a succinct answer. -2.71e+09. In the year 1998, what is the difference between the Trade (in US$) of Grenada and Trade (in US$) of United Kingdom?
Ensure brevity in your answer.  -3.88e+11. In the year 1998, what is the difference between the Trade (in US$) of Iceland and Trade (in US$) of United Kingdom?
Offer a very short reply. -3.85e+11. In the year 1999, what is the difference between the Trade (in US$) in Denmark and Trade (in US$) in Grenada?
Keep it short and to the point. 6.99e+1. In the year 1999, what is the difference between the Trade (in US$) of Denmark and Trade (in US$) of Iceland?
Provide a succinct answer. 6.72e+1. In the year 1999, what is the difference between the Trade (in US$) of Denmark and Trade (in US$) of United Kingdom?
Your response must be concise. -3.22e+11. In the year 1999, what is the difference between the Trade (in US$) of Grenada and Trade (in US$) of Iceland?
Make the answer very short. -2.70e+09. In the year 1999, what is the difference between the Trade (in US$) of Grenada and Trade (in US$) of United Kingdom?
Provide a succinct answer. -3.92e+11. In the year 1999, what is the difference between the Trade (in US$) in Iceland and Trade (in US$) in United Kingdom?
Provide a succinct answer. -3.89e+11. In the year 2000, what is the difference between the Trade (in US$) of Denmark and Trade (in US$) of Grenada?
Keep it short and to the point. 7.35e+1. In the year 2000, what is the difference between the Trade (in US$) in Denmark and Trade (in US$) in Iceland?
Your response must be concise. 7.08e+1. In the year 2000, what is the difference between the Trade (in US$) of Denmark and Trade (in US$) of United Kingdom?
Provide a succinct answer. -3.35e+11. In the year 2000, what is the difference between the Trade (in US$) of Grenada and Trade (in US$) of Iceland?
Make the answer very short. -2.66e+09. In the year 2000, what is the difference between the Trade (in US$) in Grenada and Trade (in US$) in United Kingdom?
Keep it short and to the point. -4.08e+11. In the year 2000, what is the difference between the Trade (in US$) of Iceland and Trade (in US$) of United Kingdom?
Your answer should be very brief. -4.05e+11. In the year 2001, what is the difference between the Trade (in US$) in Denmark and Trade (in US$) in Grenada?
Ensure brevity in your answer.  7.49e+1. In the year 2001, what is the difference between the Trade (in US$) in Denmark and Trade (in US$) in Iceland?
Offer a very short reply. 7.21e+1. In the year 2001, what is the difference between the Trade (in US$) of Denmark and Trade (in US$) of United Kingdom?
Provide a succinct answer. -3.25e+11. In the year 2001, what is the difference between the Trade (in US$) in Grenada and Trade (in US$) in Iceland?
Offer a terse response. -2.84e+09. In the year 2001, what is the difference between the Trade (in US$) in Grenada and Trade (in US$) in United Kingdom?
Provide a succinct answer. -4.00e+11. In the year 2001, what is the difference between the Trade (in US$) in Iceland and Trade (in US$) in United Kingdom?
Your answer should be very brief. -3.97e+11. In the year 2002, what is the difference between the Trade (in US$) in Denmark and Trade (in US$) in Grenada?
Your answer should be compact. 8.09e+1. In the year 2002, what is the difference between the Trade (in US$) of Denmark and Trade (in US$) of Iceland?
Your response must be concise. 7.78e+1. In the year 2002, what is the difference between the Trade (in US$) in Denmark and Trade (in US$) in United Kingdom?
Your answer should be compact. -3.39e+11. In the year 2002, what is the difference between the Trade (in US$) of Grenada and Trade (in US$) of Iceland?
Provide a short and direct response. -3.13e+09. In the year 2002, what is the difference between the Trade (in US$) in Grenada and Trade (in US$) in United Kingdom?
Give a very brief answer. -4.19e+11. In the year 2002, what is the difference between the Trade (in US$) in Iceland and Trade (in US$) in United Kingdom?
Your response must be concise. -4.16e+11. What is the ratio of the Trade (in US$) of Grenada in 1995 to that in 1996?
Your answer should be very brief. 0.94. What is the ratio of the Trade (in US$) in Iceland in 1995 to that in 1996?
Keep it short and to the point. 0.94. What is the ratio of the Trade (in US$) of United Kingdom in 1995 to that in 1996?
Keep it short and to the point. 0.93. What is the ratio of the Trade (in US$) of Denmark in 1995 to that in 1997?
Your answer should be compact. 1.03. What is the ratio of the Trade (in US$) of Grenada in 1995 to that in 1997?
Give a very brief answer. 0.92. What is the ratio of the Trade (in US$) in Iceland in 1995 to that in 1997?
Offer a terse response. 0.93. What is the ratio of the Trade (in US$) in United Kingdom in 1995 to that in 1997?
Make the answer very short. 0.86. What is the ratio of the Trade (in US$) of Denmark in 1995 to that in 1998?
Provide a succinct answer. 1.03. What is the ratio of the Trade (in US$) in Grenada in 1995 to that in 1998?
Your answer should be very brief. 0.79. What is the ratio of the Trade (in US$) in Iceland in 1995 to that in 1998?
Make the answer very short. 0.87. What is the ratio of the Trade (in US$) of United Kingdom in 1995 to that in 1998?
Your answer should be very brief. 0.86. What is the ratio of the Trade (in US$) in Denmark in 1995 to that in 1999?
Give a very brief answer. 0.97. What is the ratio of the Trade (in US$) in Grenada in 1995 to that in 1999?
Offer a very short reply. 0.57. What is the ratio of the Trade (in US$) of Iceland in 1995 to that in 1999?
Keep it short and to the point. 0.86. What is the ratio of the Trade (in US$) of United Kingdom in 1995 to that in 1999?
Your answer should be compact. 0.86. What is the ratio of the Trade (in US$) of Denmark in 1995 to that in 2000?
Make the answer very short. 0.92. What is the ratio of the Trade (in US$) in Grenada in 1995 to that in 2000?
Provide a succinct answer. 0.53. What is the ratio of the Trade (in US$) of Iceland in 1995 to that in 2000?
Keep it short and to the point. 0.86. What is the ratio of the Trade (in US$) of United Kingdom in 1995 to that in 2000?
Your response must be concise. 0.82. What is the ratio of the Trade (in US$) of Denmark in 1995 to that in 2001?
Give a very brief answer. 0.9. What is the ratio of the Trade (in US$) in Grenada in 1995 to that in 2001?
Give a very brief answer. 0.63. What is the ratio of the Trade (in US$) in Iceland in 1995 to that in 2001?
Offer a terse response. 0.82. What is the ratio of the Trade (in US$) in United Kingdom in 1995 to that in 2001?
Offer a terse response. 0.84. What is the ratio of the Trade (in US$) of Denmark in 1995 to that in 2002?
Your response must be concise. 0.84. What is the ratio of the Trade (in US$) in Grenada in 1995 to that in 2002?
Make the answer very short. 0.72. What is the ratio of the Trade (in US$) in Iceland in 1995 to that in 2002?
Provide a short and direct response. 0.76. What is the ratio of the Trade (in US$) in United Kingdom in 1995 to that in 2002?
Provide a succinct answer. 0.8. What is the ratio of the Trade (in US$) of Denmark in 1996 to that in 1997?
Your answer should be very brief. 1.06. What is the ratio of the Trade (in US$) of Grenada in 1996 to that in 1997?
Provide a succinct answer. 0.98. What is the ratio of the Trade (in US$) of Iceland in 1996 to that in 1997?
Your response must be concise. 0.99. What is the ratio of the Trade (in US$) in United Kingdom in 1996 to that in 1997?
Your answer should be compact. 0.92. What is the ratio of the Trade (in US$) of Denmark in 1996 to that in 1998?
Your answer should be very brief. 1.06. What is the ratio of the Trade (in US$) in Grenada in 1996 to that in 1998?
Give a very brief answer. 0.84. What is the ratio of the Trade (in US$) in Iceland in 1996 to that in 1998?
Your answer should be very brief. 0.93. What is the ratio of the Trade (in US$) of United Kingdom in 1996 to that in 1998?
Your answer should be compact. 0.93. What is the ratio of the Trade (in US$) in Denmark in 1996 to that in 1999?
Make the answer very short. 0.99. What is the ratio of the Trade (in US$) of Grenada in 1996 to that in 1999?
Keep it short and to the point. 0.6. What is the ratio of the Trade (in US$) in Iceland in 1996 to that in 1999?
Your response must be concise. 0.91. What is the ratio of the Trade (in US$) of United Kingdom in 1996 to that in 1999?
Your answer should be compact. 0.92. What is the ratio of the Trade (in US$) of Denmark in 1996 to that in 2000?
Ensure brevity in your answer.  0.95. What is the ratio of the Trade (in US$) in Grenada in 1996 to that in 2000?
Ensure brevity in your answer.  0.56. What is the ratio of the Trade (in US$) of Iceland in 1996 to that in 2000?
Provide a short and direct response. 0.92. What is the ratio of the Trade (in US$) of United Kingdom in 1996 to that in 2000?
Keep it short and to the point. 0.89. What is the ratio of the Trade (in US$) in Denmark in 1996 to that in 2001?
Provide a succinct answer. 0.93. What is the ratio of the Trade (in US$) of Grenada in 1996 to that in 2001?
Ensure brevity in your answer.  0.67. What is the ratio of the Trade (in US$) in Iceland in 1996 to that in 2001?
Offer a terse response. 0.87. What is the ratio of the Trade (in US$) of United Kingdom in 1996 to that in 2001?
Offer a terse response. 0.91. What is the ratio of the Trade (in US$) in Denmark in 1996 to that in 2002?
Provide a succinct answer. 0.86. What is the ratio of the Trade (in US$) of Grenada in 1996 to that in 2002?
Your response must be concise. 0.76. What is the ratio of the Trade (in US$) in Iceland in 1996 to that in 2002?
Provide a short and direct response. 0.81. What is the ratio of the Trade (in US$) in United Kingdom in 1996 to that in 2002?
Offer a very short reply. 0.86. What is the ratio of the Trade (in US$) in Grenada in 1997 to that in 1998?
Keep it short and to the point. 0.85. What is the ratio of the Trade (in US$) of Iceland in 1997 to that in 1998?
Offer a very short reply. 0.94. What is the ratio of the Trade (in US$) in Denmark in 1997 to that in 1999?
Your answer should be very brief. 0.94. What is the ratio of the Trade (in US$) of Grenada in 1997 to that in 1999?
Your answer should be very brief. 0.61. What is the ratio of the Trade (in US$) in Iceland in 1997 to that in 1999?
Give a very brief answer. 0.92. What is the ratio of the Trade (in US$) of United Kingdom in 1997 to that in 1999?
Your answer should be very brief. 1. What is the ratio of the Trade (in US$) of Denmark in 1997 to that in 2000?
Provide a short and direct response. 0.89. What is the ratio of the Trade (in US$) of Grenada in 1997 to that in 2000?
Give a very brief answer. 0.57. What is the ratio of the Trade (in US$) of Iceland in 1997 to that in 2000?
Ensure brevity in your answer.  0.93. What is the ratio of the Trade (in US$) in United Kingdom in 1997 to that in 2000?
Provide a succinct answer. 0.96. What is the ratio of the Trade (in US$) of Denmark in 1997 to that in 2001?
Provide a short and direct response. 0.87. What is the ratio of the Trade (in US$) in Grenada in 1997 to that in 2001?
Provide a succinct answer. 0.68. What is the ratio of the Trade (in US$) in Iceland in 1997 to that in 2001?
Keep it short and to the point. 0.88. What is the ratio of the Trade (in US$) in United Kingdom in 1997 to that in 2001?
Make the answer very short. 0.98. What is the ratio of the Trade (in US$) of Denmark in 1997 to that in 2002?
Keep it short and to the point. 0.81. What is the ratio of the Trade (in US$) in Grenada in 1997 to that in 2002?
Your response must be concise. 0.78. What is the ratio of the Trade (in US$) of Iceland in 1997 to that in 2002?
Your answer should be compact. 0.81. What is the ratio of the Trade (in US$) of United Kingdom in 1997 to that in 2002?
Provide a short and direct response. 0.93. What is the ratio of the Trade (in US$) in Denmark in 1998 to that in 1999?
Make the answer very short. 0.94. What is the ratio of the Trade (in US$) of Grenada in 1998 to that in 1999?
Provide a short and direct response. 0.72. What is the ratio of the Trade (in US$) of United Kingdom in 1998 to that in 1999?
Your answer should be compact. 0.99. What is the ratio of the Trade (in US$) in Denmark in 1998 to that in 2000?
Keep it short and to the point. 0.89. What is the ratio of the Trade (in US$) of Grenada in 1998 to that in 2000?
Keep it short and to the point. 0.67. What is the ratio of the Trade (in US$) in Iceland in 1998 to that in 2000?
Ensure brevity in your answer.  0.99. What is the ratio of the Trade (in US$) of United Kingdom in 1998 to that in 2000?
Ensure brevity in your answer.  0.95. What is the ratio of the Trade (in US$) in Denmark in 1998 to that in 2001?
Keep it short and to the point. 0.88. What is the ratio of the Trade (in US$) in Grenada in 1998 to that in 2001?
Your answer should be compact. 0.8. What is the ratio of the Trade (in US$) in Iceland in 1998 to that in 2001?
Provide a short and direct response. 0.94. What is the ratio of the Trade (in US$) in United Kingdom in 1998 to that in 2001?
Your answer should be very brief. 0.97. What is the ratio of the Trade (in US$) in Denmark in 1998 to that in 2002?
Your answer should be compact. 0.81. What is the ratio of the Trade (in US$) in Grenada in 1998 to that in 2002?
Your answer should be very brief. 0.91. What is the ratio of the Trade (in US$) of Iceland in 1998 to that in 2002?
Give a very brief answer. 0.87. What is the ratio of the Trade (in US$) of United Kingdom in 1998 to that in 2002?
Keep it short and to the point. 0.92. What is the ratio of the Trade (in US$) of Denmark in 1999 to that in 2000?
Your response must be concise. 0.95. What is the ratio of the Trade (in US$) of Grenada in 1999 to that in 2000?
Ensure brevity in your answer.  0.93. What is the ratio of the Trade (in US$) of Iceland in 1999 to that in 2000?
Provide a short and direct response. 1.01. What is the ratio of the Trade (in US$) in United Kingdom in 1999 to that in 2000?
Your answer should be very brief. 0.96. What is the ratio of the Trade (in US$) in Denmark in 1999 to that in 2001?
Give a very brief answer. 0.93. What is the ratio of the Trade (in US$) in Grenada in 1999 to that in 2001?
Provide a short and direct response. 1.11. What is the ratio of the Trade (in US$) of Iceland in 1999 to that in 2001?
Keep it short and to the point. 0.96. What is the ratio of the Trade (in US$) in United Kingdom in 1999 to that in 2001?
Your answer should be very brief. 0.98. What is the ratio of the Trade (in US$) of Denmark in 1999 to that in 2002?
Keep it short and to the point. 0.86. What is the ratio of the Trade (in US$) in Grenada in 1999 to that in 2002?
Ensure brevity in your answer.  1.26. What is the ratio of the Trade (in US$) in Iceland in 1999 to that in 2002?
Make the answer very short. 0.88. What is the ratio of the Trade (in US$) in United Kingdom in 1999 to that in 2002?
Provide a succinct answer. 0.93. What is the ratio of the Trade (in US$) in Denmark in 2000 to that in 2001?
Your answer should be compact. 0.98. What is the ratio of the Trade (in US$) of Grenada in 2000 to that in 2001?
Give a very brief answer. 1.2. What is the ratio of the Trade (in US$) in Iceland in 2000 to that in 2001?
Provide a short and direct response. 0.95. What is the ratio of the Trade (in US$) in United Kingdom in 2000 to that in 2001?
Your response must be concise. 1.02. What is the ratio of the Trade (in US$) in Denmark in 2000 to that in 2002?
Your response must be concise. 0.91. What is the ratio of the Trade (in US$) in Grenada in 2000 to that in 2002?
Offer a very short reply. 1.37. What is the ratio of the Trade (in US$) of Iceland in 2000 to that in 2002?
Provide a short and direct response. 0.88. What is the ratio of the Trade (in US$) in United Kingdom in 2000 to that in 2002?
Give a very brief answer. 0.97. What is the ratio of the Trade (in US$) of Denmark in 2001 to that in 2002?
Make the answer very short. 0.93. What is the ratio of the Trade (in US$) of Grenada in 2001 to that in 2002?
Offer a very short reply. 1.14. What is the ratio of the Trade (in US$) of Iceland in 2001 to that in 2002?
Your answer should be very brief. 0.92. What is the ratio of the Trade (in US$) in United Kingdom in 2001 to that in 2002?
Provide a succinct answer. 0.95. What is the difference between the highest and the second highest Trade (in US$) in Denmark?
Offer a very short reply. 5.96e+09. What is the difference between the highest and the second highest Trade (in US$) of Grenada?
Give a very brief answer. 1.77e+07. What is the difference between the highest and the second highest Trade (in US$) in Iceland?
Your answer should be very brief. 2.62e+08. What is the difference between the highest and the second highest Trade (in US$) of United Kingdom?
Provide a short and direct response. 1.14e+1. What is the difference between the highest and the lowest Trade (in US$) in Denmark?
Keep it short and to the point. 1.55e+1. What is the difference between the highest and the lowest Trade (in US$) in Grenada?
Provide a short and direct response. 1.12e+08. What is the difference between the highest and the lowest Trade (in US$) of Iceland?
Give a very brief answer. 8.09e+08. What is the difference between the highest and the lowest Trade (in US$) in United Kingdom?
Your answer should be very brief. 8.40e+1. 